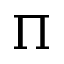<formula> <loc_0><loc_0><loc_500><loc_500>\Pi</formula> 